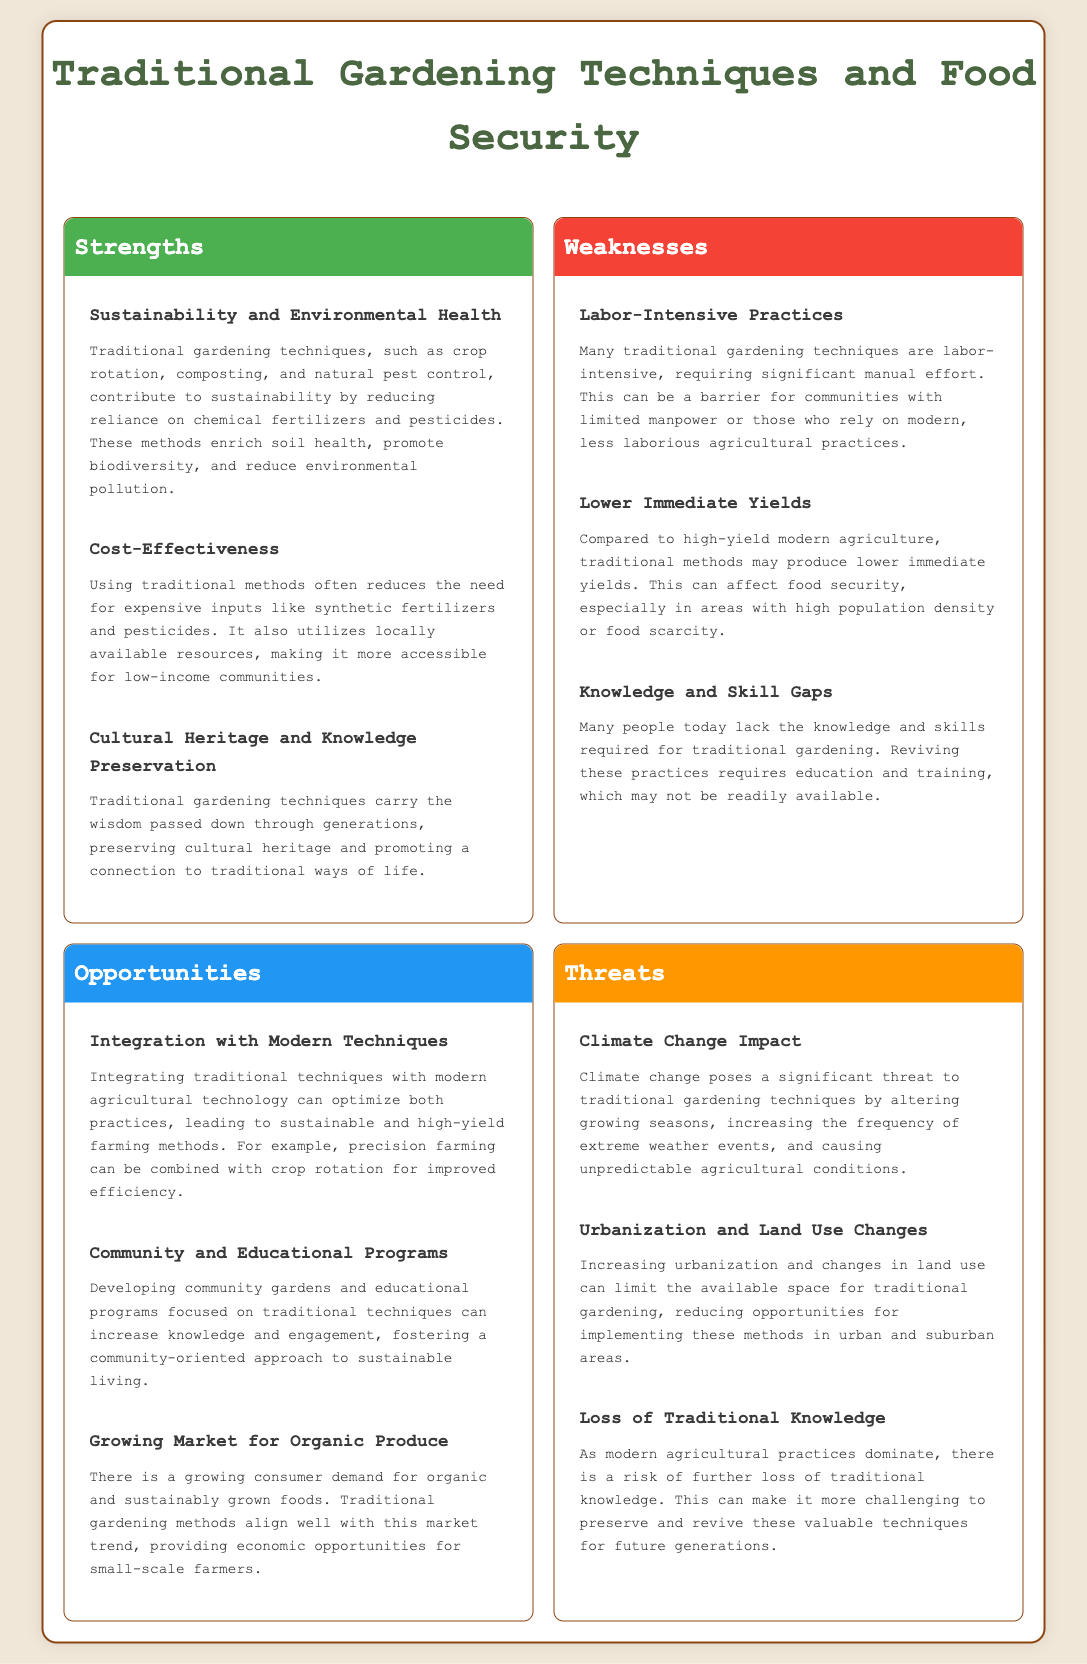What is one strength of traditional gardening techniques? The document lists sustainability and environmental health as a strength, highlighting the benefits of methods like crop rotation and composting.
Answer: Sustainability and Environmental Health What is a weakness associated with traditional gardening techniques? The document mentions that labor-intensive practices are a weakness, which can be a barrier for some communities.
Answer: Labor-Intensive Practices What type of opportunity is mentioned regarding community involvement? The document discusses developing community gardens and educational programs as an opportunity to increase engagement with traditional practices.
Answer: Community and Educational Programs What threat does climate change pose to traditional gardening? According to the document, climate change can alter growing seasons and increase extreme weather events, impacting traditional gardening.
Answer: Climate Change Impact How many strengths are listed in the SWOT analysis? The document outlines three distinct strengths associated with traditional gardening techniques.
Answer: Three What traditional gardening technique contributes to cost-effectiveness? The document highlights that using locally available resources in traditional methods reduces reliance on expensive inputs, making them cost-effective.
Answer: Utilizing locally available resources What growing trend aligns with traditional gardening methods? The document states that there is a growing market for organic produce, which aligns well with traditional gardening methods.
Answer: Growing Market for Organic Produce What does the document suggest is necessary for reviving traditional gardening? The document notes that education and training are necessary to address the knowledge and skill gaps in traditional gardening methods.
Answer: Education and training 